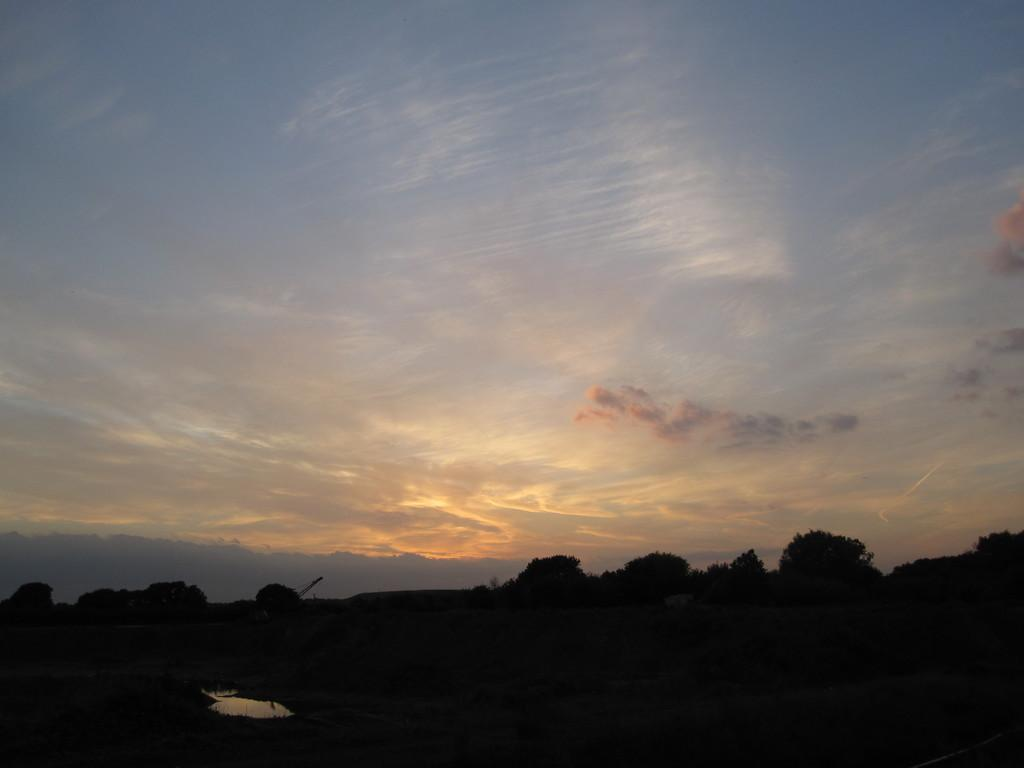What is visible at the top of the image? The sky is visible at the top of the image. What can be seen at the bottom of the image? There are trees at the bottom of the image. Can you describe the time of day when the image was taken? The image was taken during early morning. How many hooks are hanging from the trees in the image? There are no hooks visible in the image; it only shows trees at the bottom and the sky at the top. What type of lumber is being used to construct the buildings in the image? There are no buildings present in the image, only trees and the sky. 